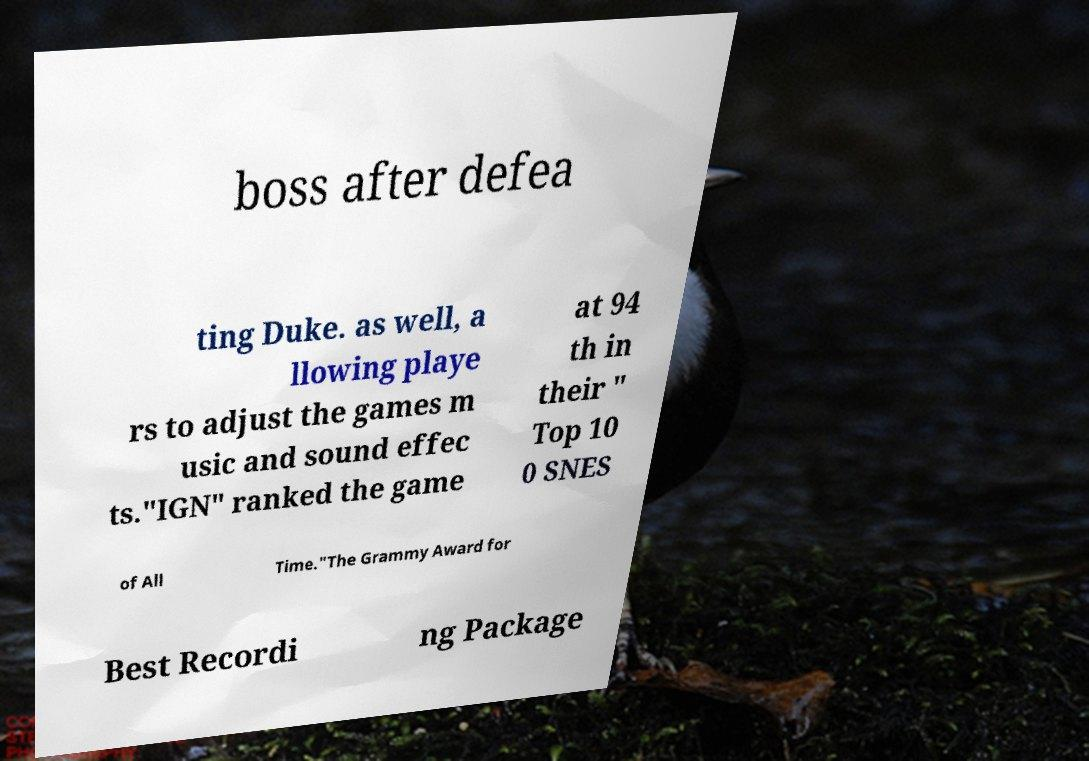What messages or text are displayed in this image? I need them in a readable, typed format. boss after defea ting Duke. as well, a llowing playe rs to adjust the games m usic and sound effec ts."IGN" ranked the game at 94 th in their " Top 10 0 SNES of All Time."The Grammy Award for Best Recordi ng Package 